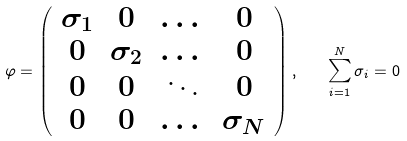Convert formula to latex. <formula><loc_0><loc_0><loc_500><loc_500>\varphi = \left ( \begin{array} { c c c c } \sigma _ { 1 } & 0 & \dots & 0 \\ 0 & \sigma _ { 2 } & \dots & 0 \\ 0 & 0 & \ddots & 0 \\ 0 & 0 & \dots & \sigma _ { N } \end{array} \right ) , \quad \sum _ { i = 1 } ^ { N } \sigma _ { i } = 0</formula> 